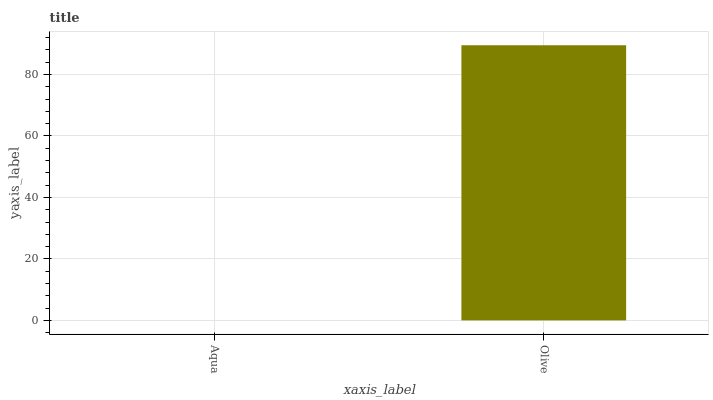Is Aqua the minimum?
Answer yes or no. Yes. Is Olive the maximum?
Answer yes or no. Yes. Is Olive the minimum?
Answer yes or no. No. Is Olive greater than Aqua?
Answer yes or no. Yes. Is Aqua less than Olive?
Answer yes or no. Yes. Is Aqua greater than Olive?
Answer yes or no. No. Is Olive less than Aqua?
Answer yes or no. No. Is Olive the high median?
Answer yes or no. Yes. Is Aqua the low median?
Answer yes or no. Yes. Is Aqua the high median?
Answer yes or no. No. Is Olive the low median?
Answer yes or no. No. 